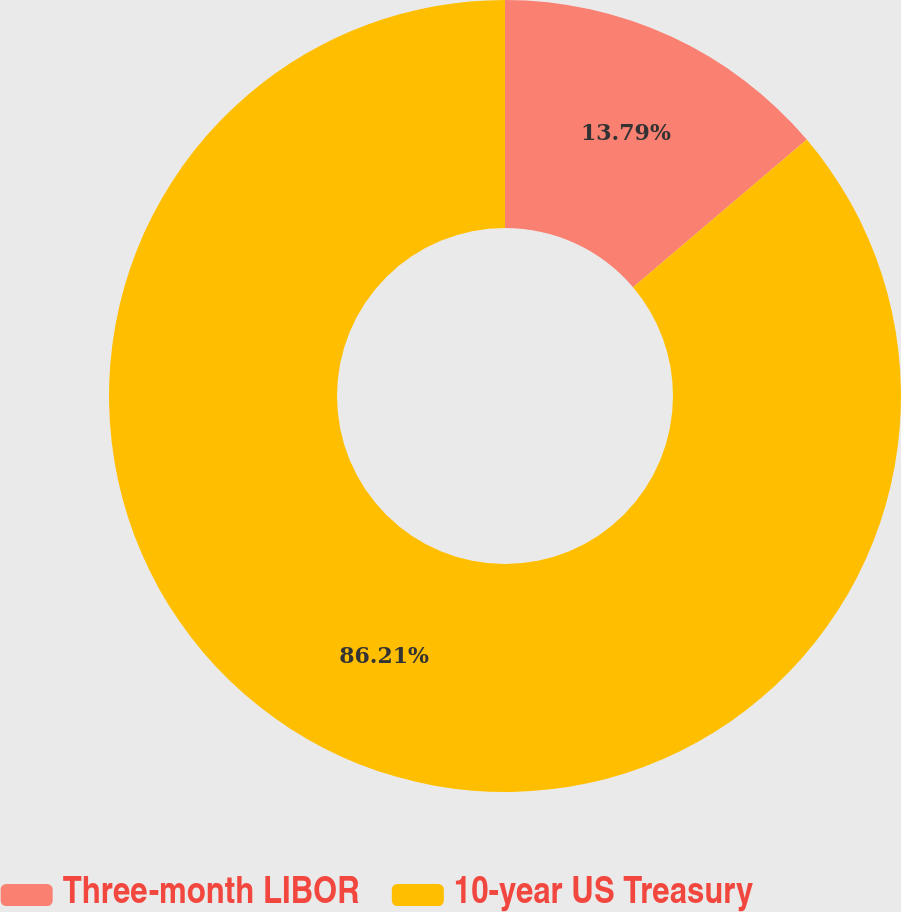Convert chart to OTSL. <chart><loc_0><loc_0><loc_500><loc_500><pie_chart><fcel>Three-month LIBOR<fcel>10-year US Treasury<nl><fcel>13.79%<fcel>86.21%<nl></chart> 